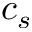Convert formula to latex. <formula><loc_0><loc_0><loc_500><loc_500>c _ { s }</formula> 